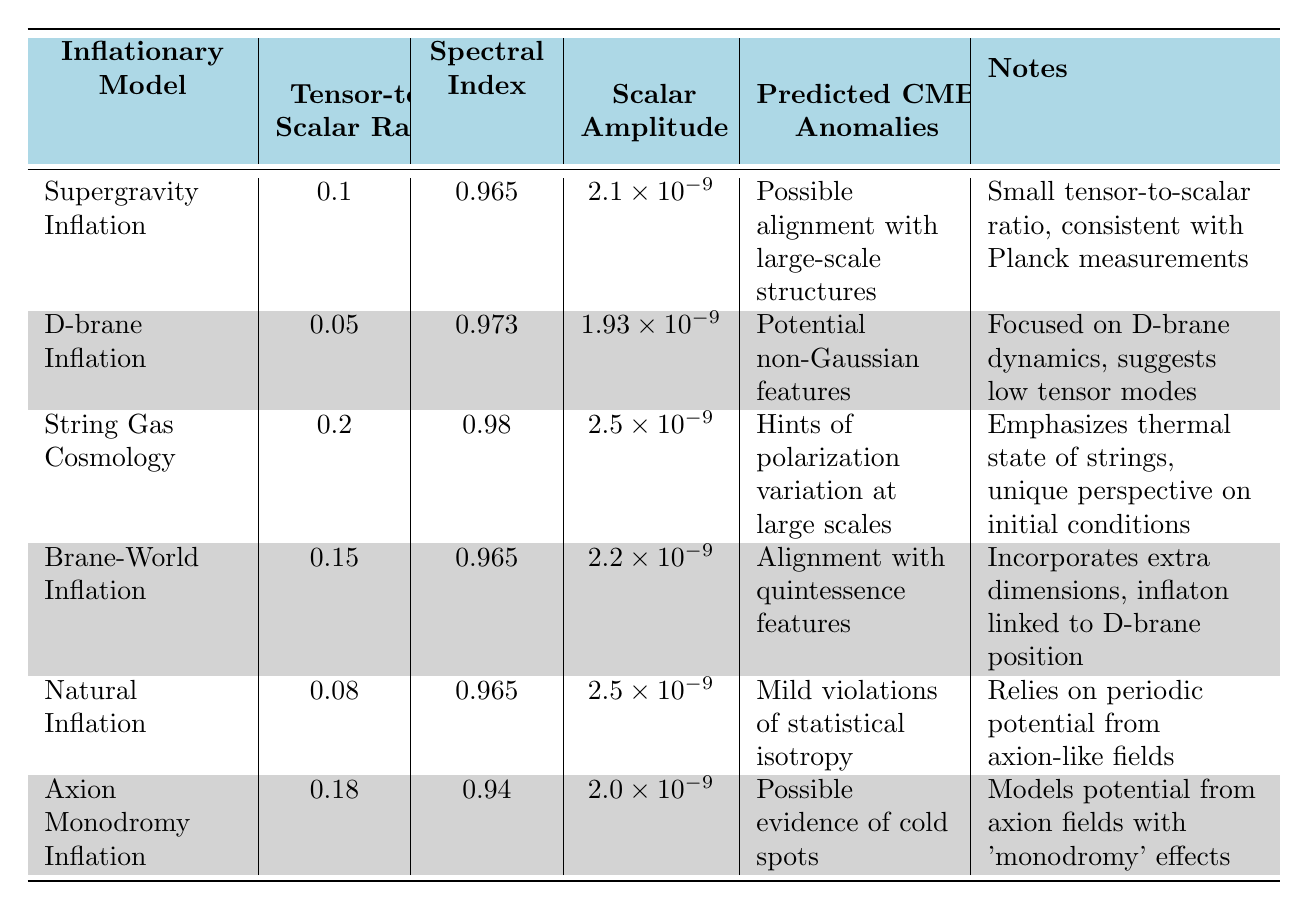What is the tensor-to-scalar ratio for D-brane Inflation? Referring to the table, the value associated with D-brane Inflation under the column "Tensor-to-Scalar Ratio" is 0.05.
Answer: 0.05 What are the predicted CMB anomalies for String Gas Cosmology? Looking at the "Predicted CMB Anomalies" column for String Gas Cosmology, it states "Hints of polarization variation at large scales."
Answer: Hints of polarization variation at large scales Which inflationary model has the highest scalar amplitude? The scalar amplitudes listed are: Supergravity Inflation (2.1e-9), D-brane Inflation (1.93e-9), String Gas Cosmology (2.5e-9), Brane-World Inflation (2.2e-9), Natural Inflation (2.5e-9), and Axion Monodromy Inflation (2.0e-9). Both String Gas Cosmology and Natural Inflation have the highest scalar amplitude at 2.5e-9.
Answer: String Gas Cosmology and Natural Inflation What is the average tensor-to-scalar ratio of the models listed? The tensor-to-scalar ratios are: 0.1, 0.05, 0.2, 0.15, 0.08, and 0.18. Summing these: 0.1 + 0.05 + 0.2 + 0.15 + 0.08 + 0.18 = 0.76. There are 6 models, so the average is 0.76/6 = approximately 0.1267.
Answer: 0.1267 Does Axion Monodromy Inflation predict any CMB anomalies? Referring to the "Predicted CMB Anomalies" column for Axion Monodromy Inflation, it states "Possible evidence of cold spots," which confirms it predicts CMB anomalies.
Answer: Yes Which model has the lowest spectral index? Analyzing the "Spectral Index" values: Supergravity Inflation (0.965), D-brane Inflation (0.973), String Gas Cosmology (0.98), Brane-World Inflation (0.965), Natural Inflation (0.965), and Axion Monodromy Inflation (0.94), the lowest spectral index is 0.94, corresponding to Axion Monodromy Inflation.
Answer: Axion Monodromy Inflation Are there any models predicted to have alignment anomalies with large-scale structures? Checking the "Predicted CMB Anomalies" column, Supergravity Inflation lists "Possible alignment with large-scale structures," indicating yes, this model has such predictions.
Answer: Yes Which model predicts potential non-Gaussian features? Referring to the table, D-brane Inflation mentions "Potential non-Gaussian features" in the "Predicted CMB Anomalies" column, indicating that this model makes such predictions.
Answer: D-brane Inflation 